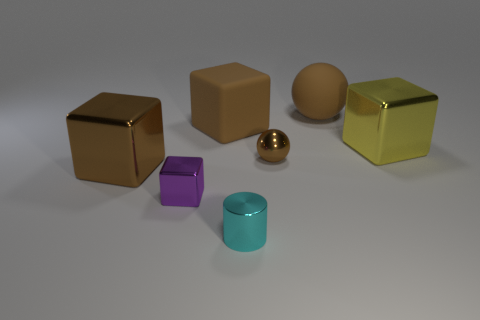There is a large brown matte sphere behind the small cyan object; what number of large matte objects are in front of it?
Make the answer very short. 1. Are there any big blue rubber balls?
Your answer should be compact. No. What number of other things are the same color as the big rubber cube?
Provide a short and direct response. 3. Is the number of tiny cyan cylinders less than the number of tiny cyan shiny cubes?
Your answer should be very brief. No. The large thing in front of the large metal object that is on the right side of the big brown matte ball is what shape?
Make the answer very short. Cube. Are there any yellow metallic things behind the small purple block?
Keep it short and to the point. Yes. What is the color of the metal block that is the same size as the metallic cylinder?
Give a very brief answer. Purple. How many small cylinders are the same material as the large yellow block?
Offer a terse response. 1. How many other things are there of the same size as the cyan shiny cylinder?
Offer a terse response. 2. Are there any green things that have the same size as the rubber block?
Provide a succinct answer. No. 